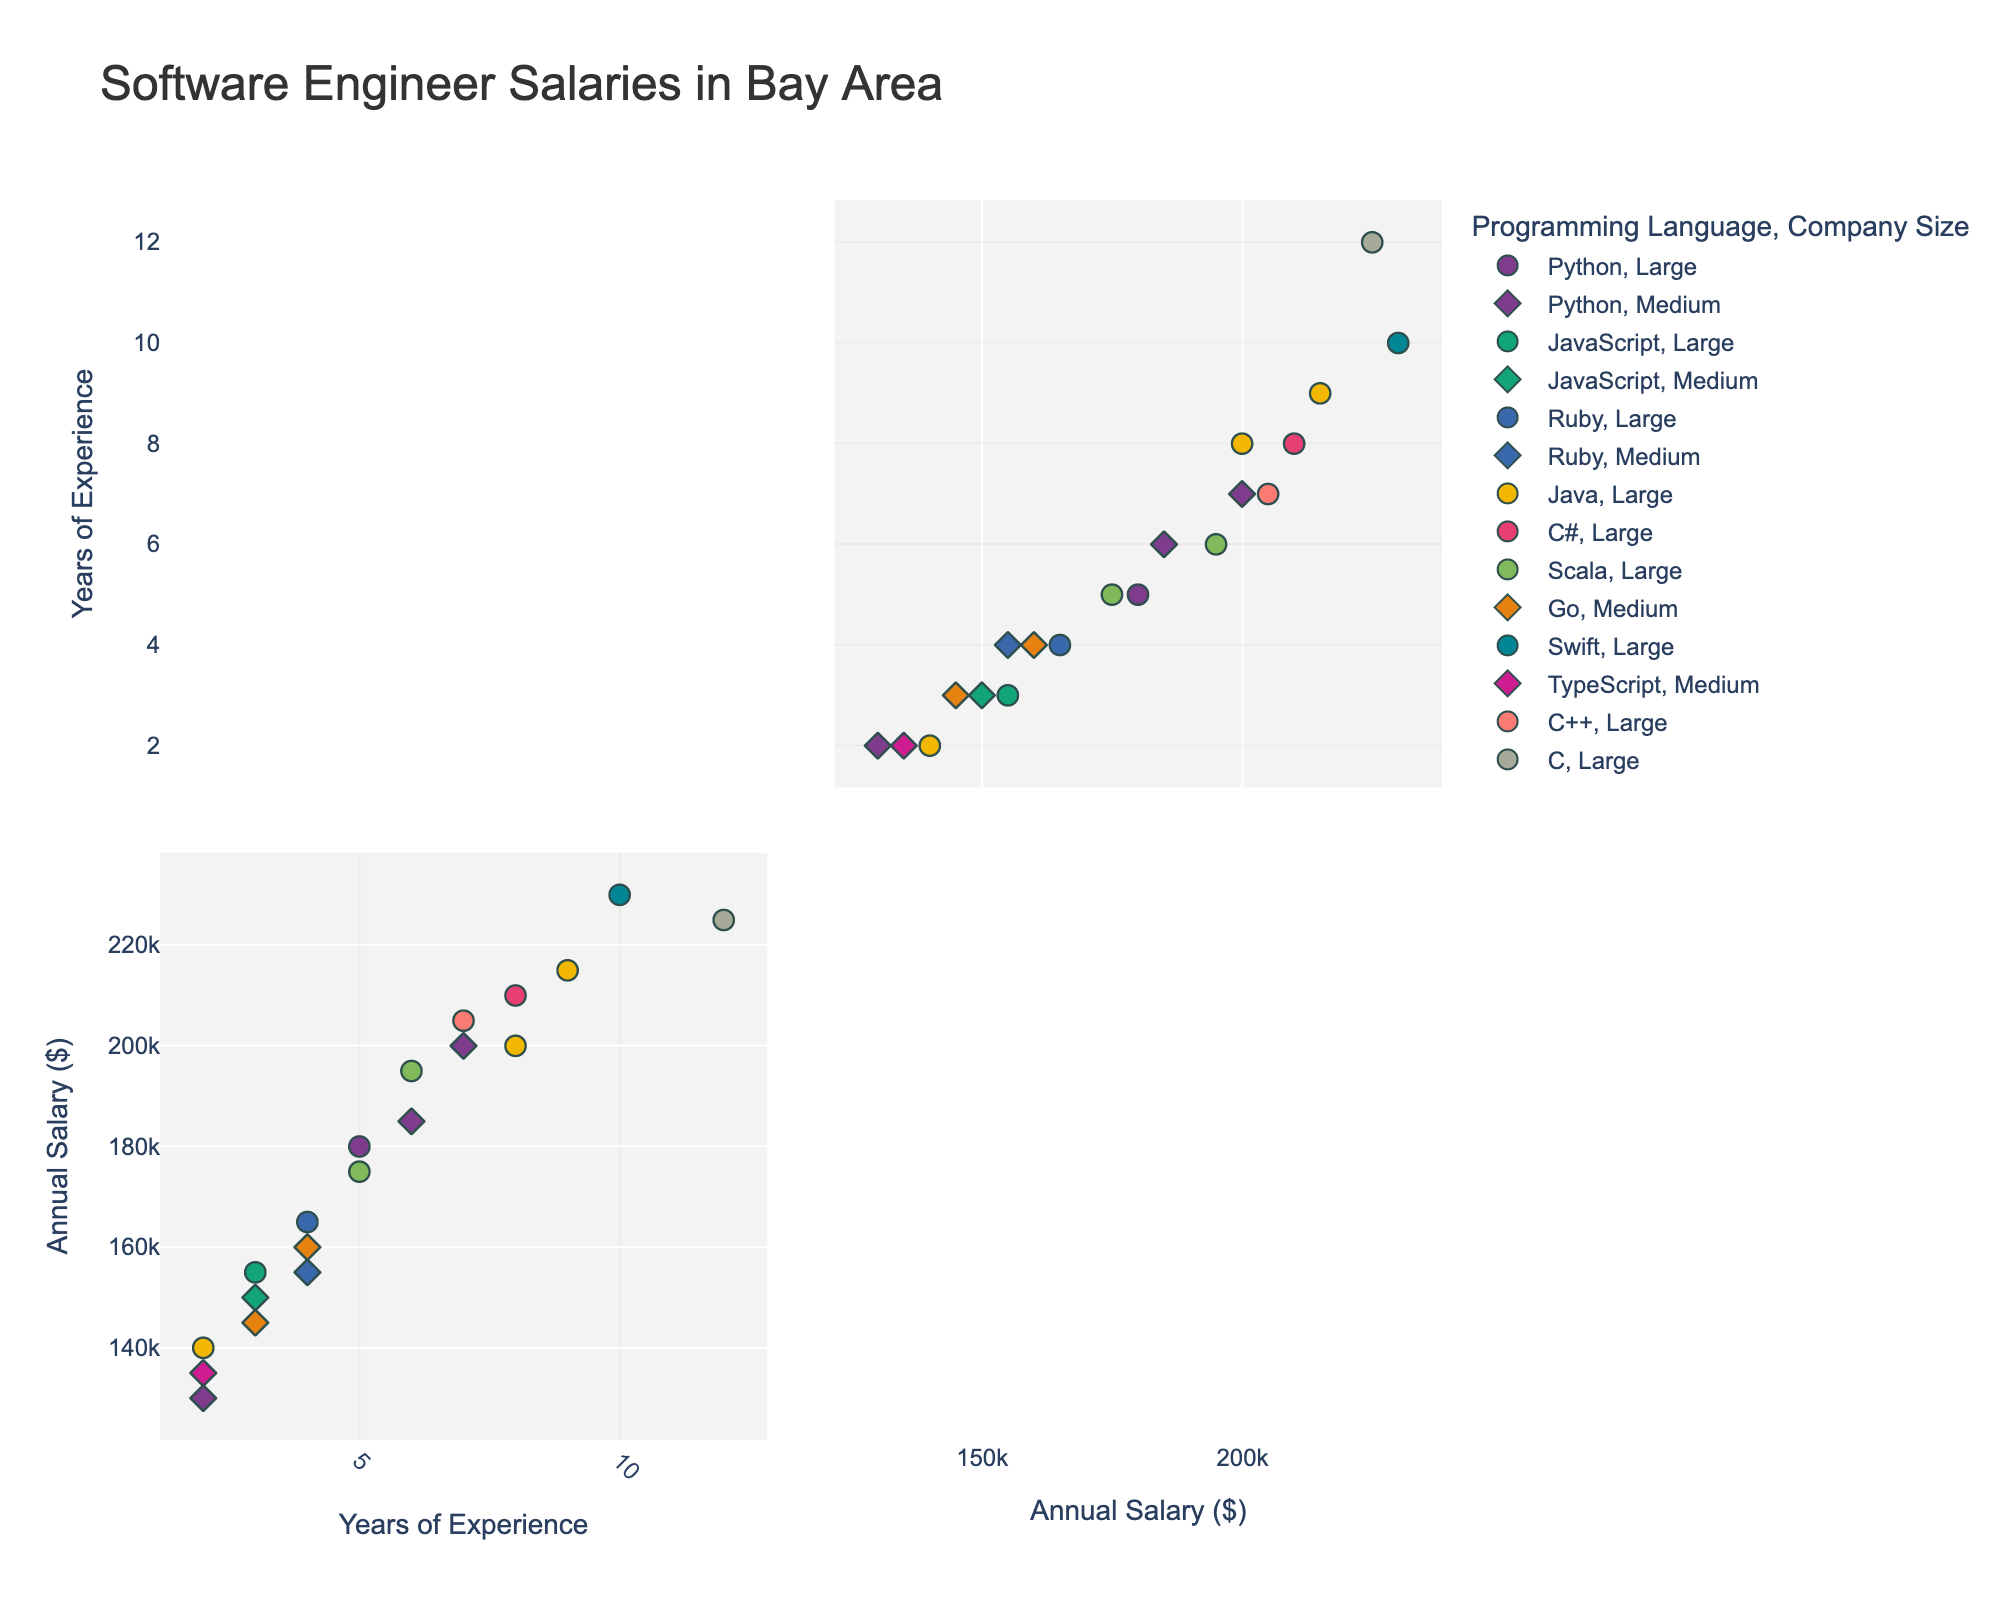What is the title of the figure? The title of the scatterplot matrix is typically found at the top and summarizes the main content of the plot. In this case, the title "Software Engineer Salaries in Bay Area" is displayed.
Answer: Software Engineer Salaries in Bay Area What are the axis labels for the scatterplot matrix? The axis labels are indicated on the respective axes of the scatterplot matrix. The x and y axes here are labeled "Years of Experience" and "Annual Salary ($)".
Answer: Years of Experience, Annual Salary ($) How many companies are represented in the plot? The hover_data attribute in the code includes a column for 'Company', allowing you to count the unique number of companies. From the data provided, there are 20 unique companies listed.
Answer: 20 Which company has the highest annual salary? By identifying the highest value on the Annual Salary axis and checking the corresponding data point’s hover information, the company with the highest salary can be found. Apple has the highest annual salary of $230,000.
Answer: Apple How many companies fall under the 'Medium' company size category? The 'Size' dimension is visualized with symbols, making it easy to count the occurrences of the 'Medium' symbol. There are 8 companies categorized as 'Medium'.
Answer: 8 What is the range of years of experience for the software engineers in this scatterplot? Observing the x-axis (Years of Experience) on the scatterplot matrix, the minimum value is 2 years, and the maximum value is 12 years. Therefore, the range is 12 - 2 = 10 years.
Answer: 10 years Which programming language corresponds to the highest annual salary? The color of the data point representing the highest annual salary can be compared with the color legend for 'Programming Language'. The highest salary of $230,000 is associated with the Swift language.
Answer: Swift What is the average annual salary for software engineers with 5 years of experience? Locate all data points where the x-axis value is 5 (Years of Experience) and average their annual salaries: (180000 + 175000)/2 = 355000/2 = 177500.
Answer: 177,500 Compare the annual salary of a software engineer with 3 years of experience at Google to someone with the same experience at Square. Who earns more? Identify the data points for Google and Square with 3 years of experience and compare their y-axis (Annual Salary) values. A software engineer at Google has an annual salary of $180,000, while another at Square gets $145,000. Therefore, the Google engineer earns more.
Answer: Google Which programming language has the most data points on the scatterplot matrix? By examining the color-coded scatterplot, count the number of occurrences for each programming language. Python appears most frequently with 4 data points.
Answer: Python 